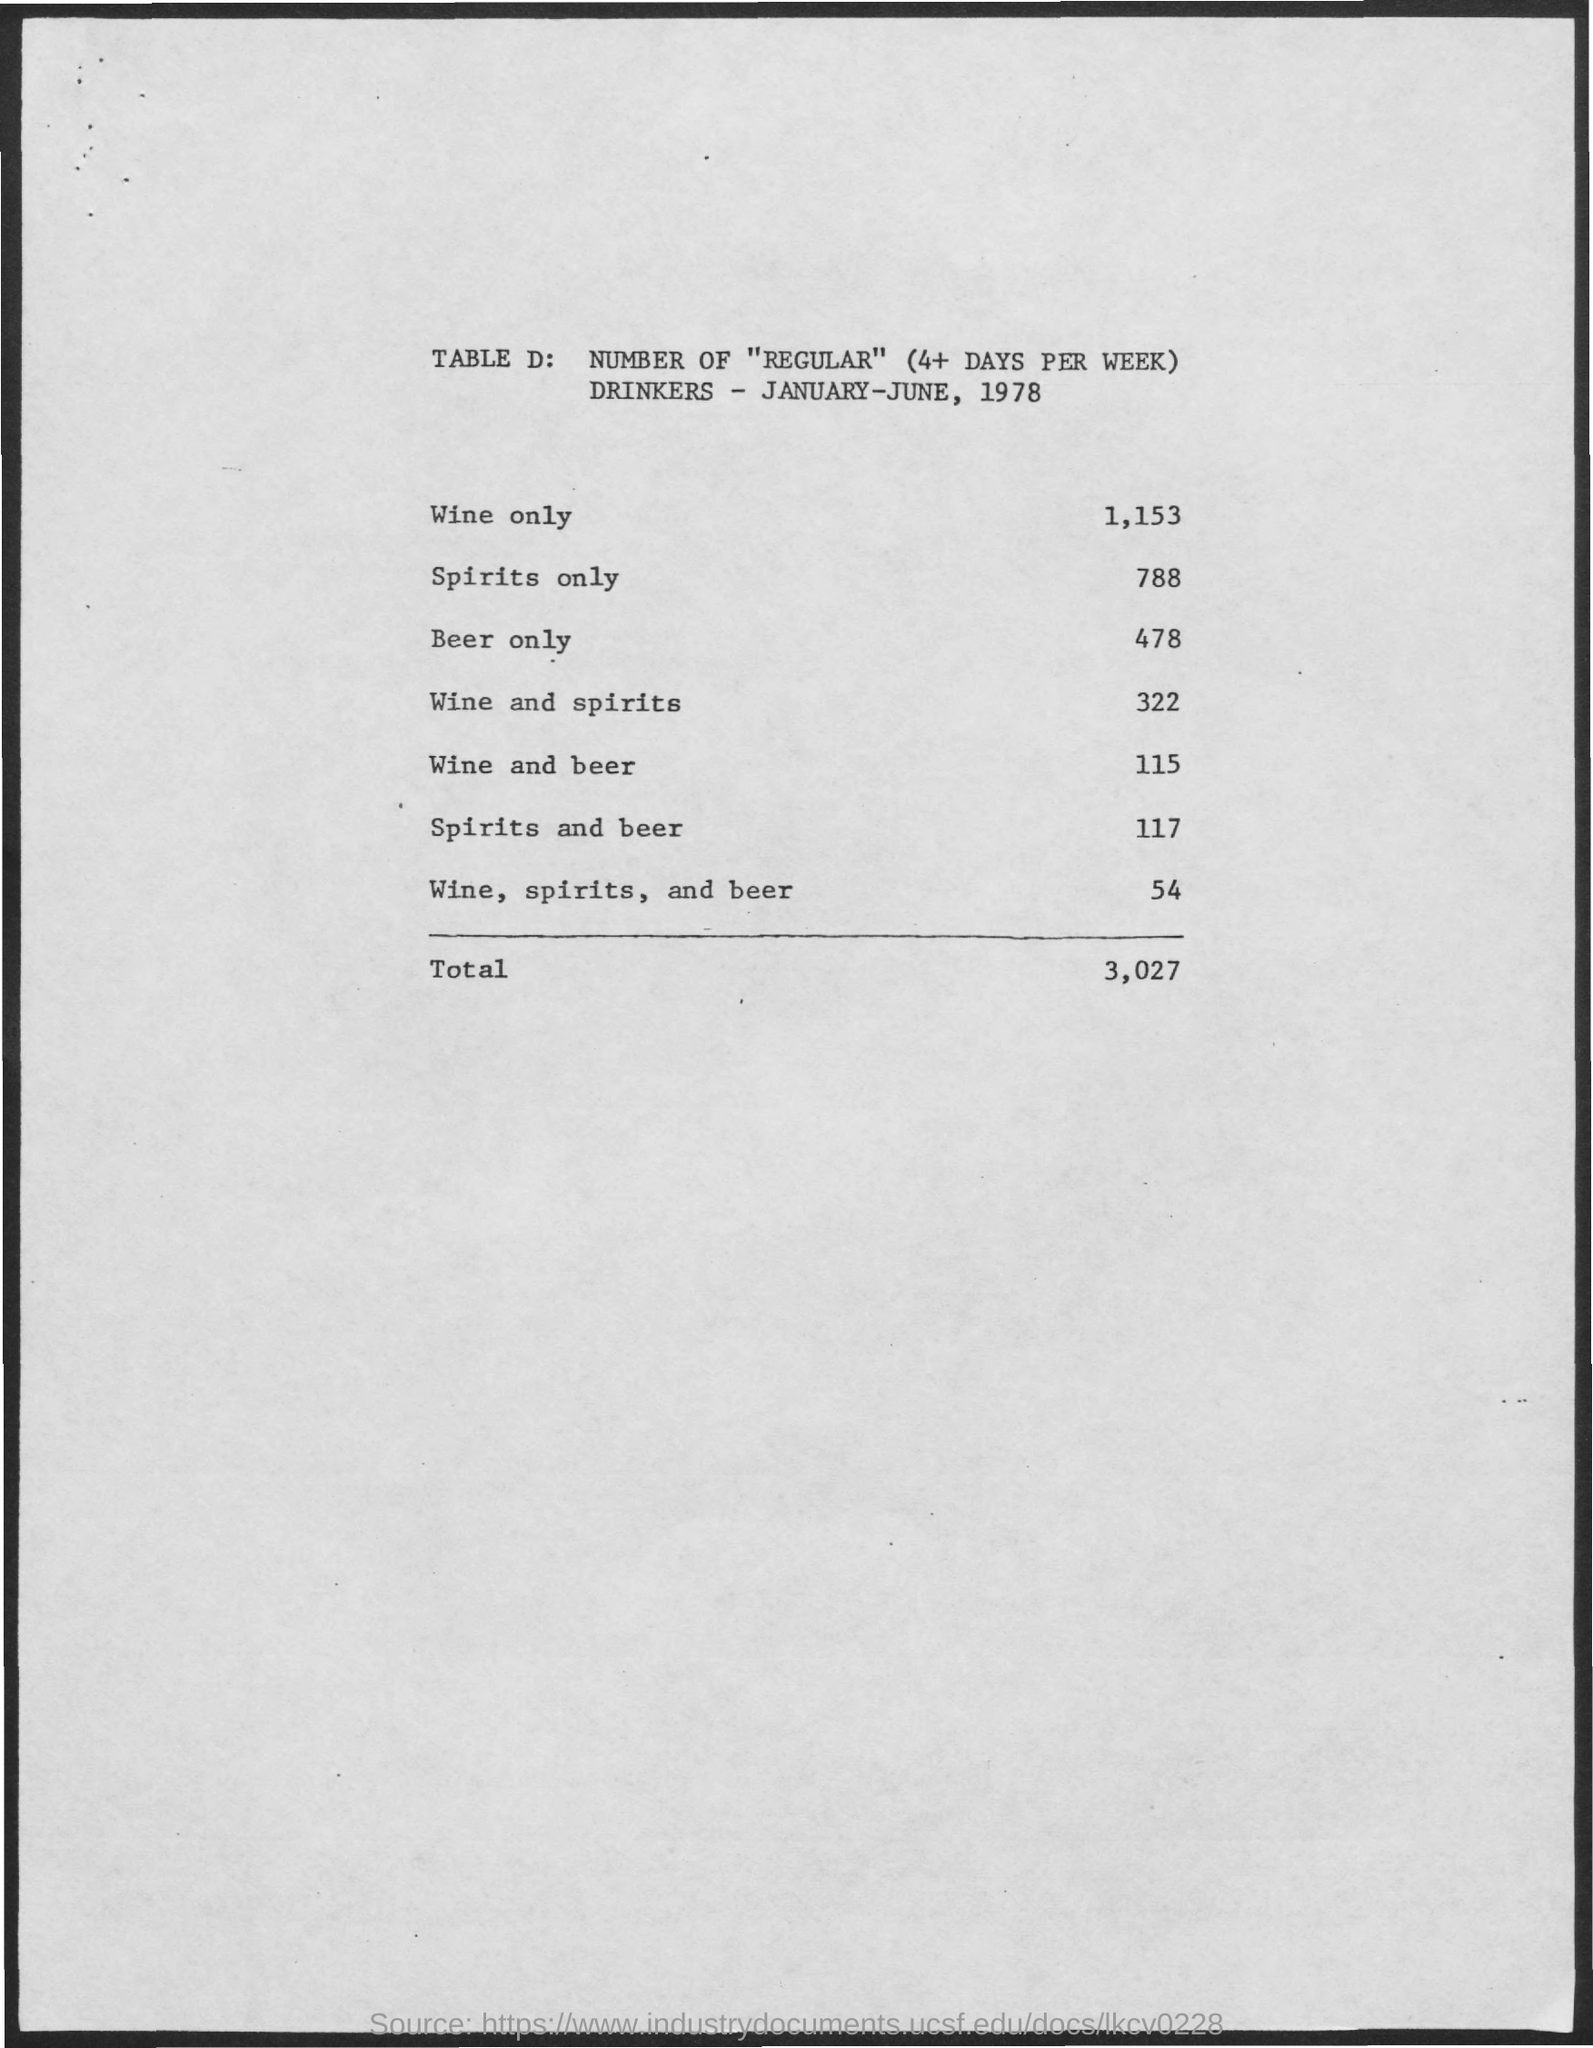Mention a couple of crucial points in this snapshot. There are 115 individuals who consume both wine and beer. There are 117 individuals who consume both spirits and beer. There are 478 people who only drink beer. There are 1,153 regular drinkers who only consume wine. There are 322 people who consume both wine and spirits. 